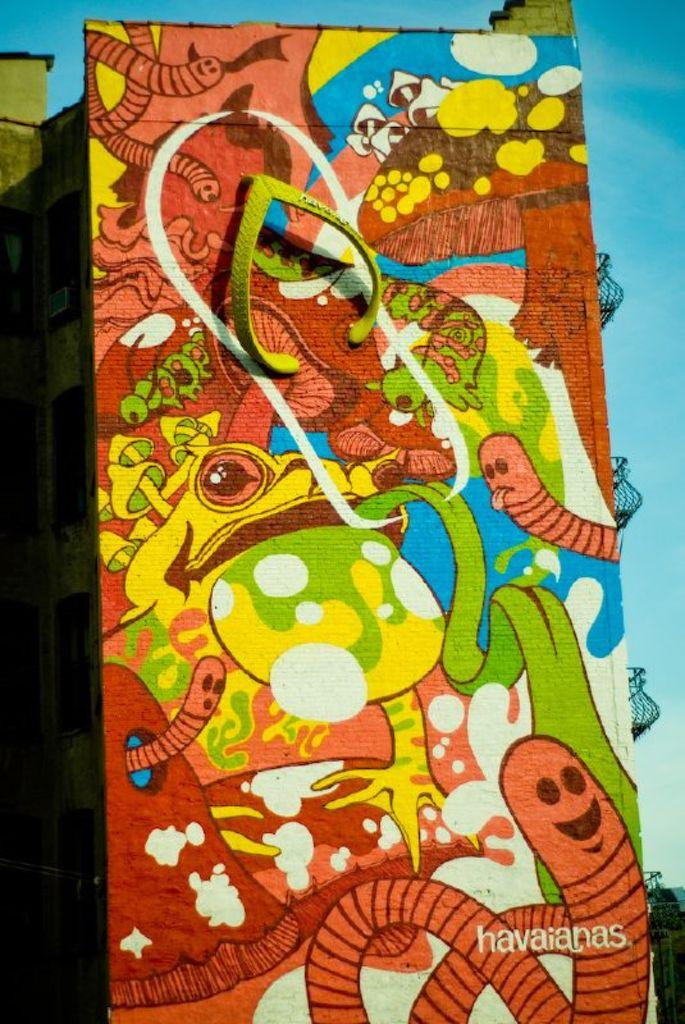What is the main subject of the image? The main subject of the image is a building wall. What can be seen on the wall? There are paintings on the wall, including a picture of a slipper. What architectural feature is visible on the right side of the image? There are balconies on the right side of the image. What is visible at the top of the image? The sky is visible at the top of the image. What type of plant is being watered by the hand in the image? There is no hand or plant present in the image; it features a building wall with paintings on it. 